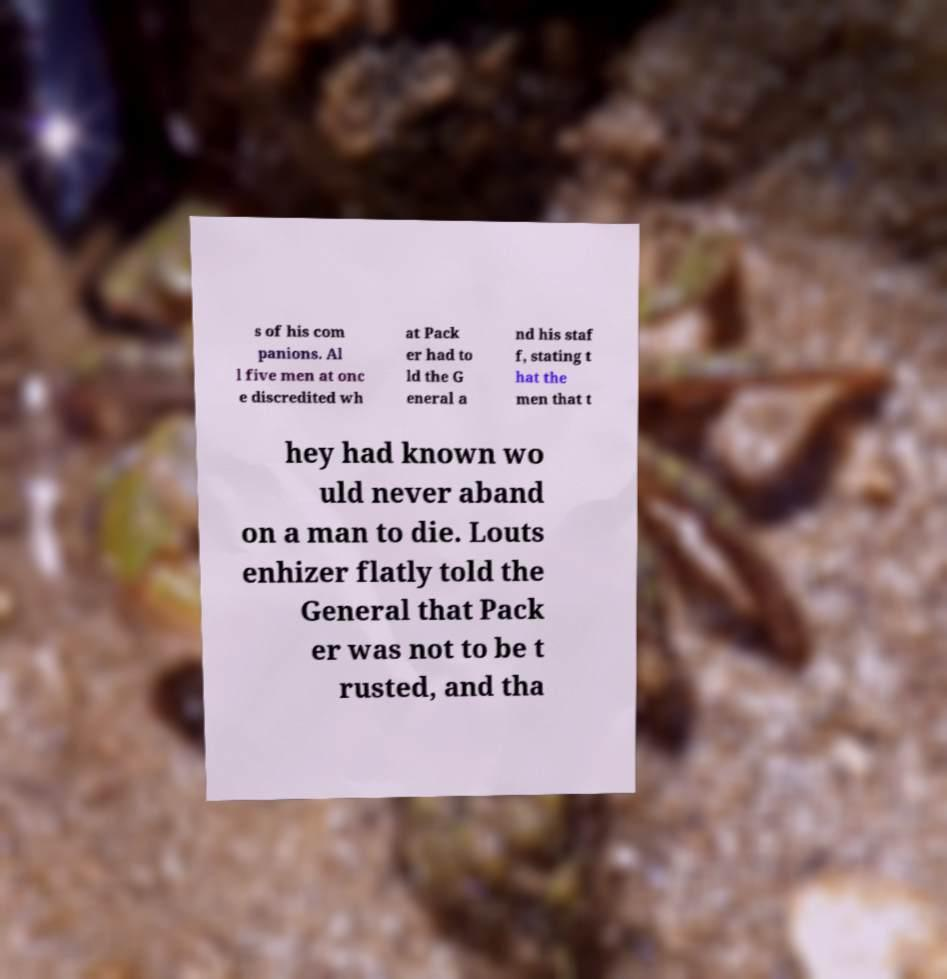For documentation purposes, I need the text within this image transcribed. Could you provide that? s of his com panions. Al l five men at onc e discredited wh at Pack er had to ld the G eneral a nd his staf f, stating t hat the men that t hey had known wo uld never aband on a man to die. Louts enhizer flatly told the General that Pack er was not to be t rusted, and tha 